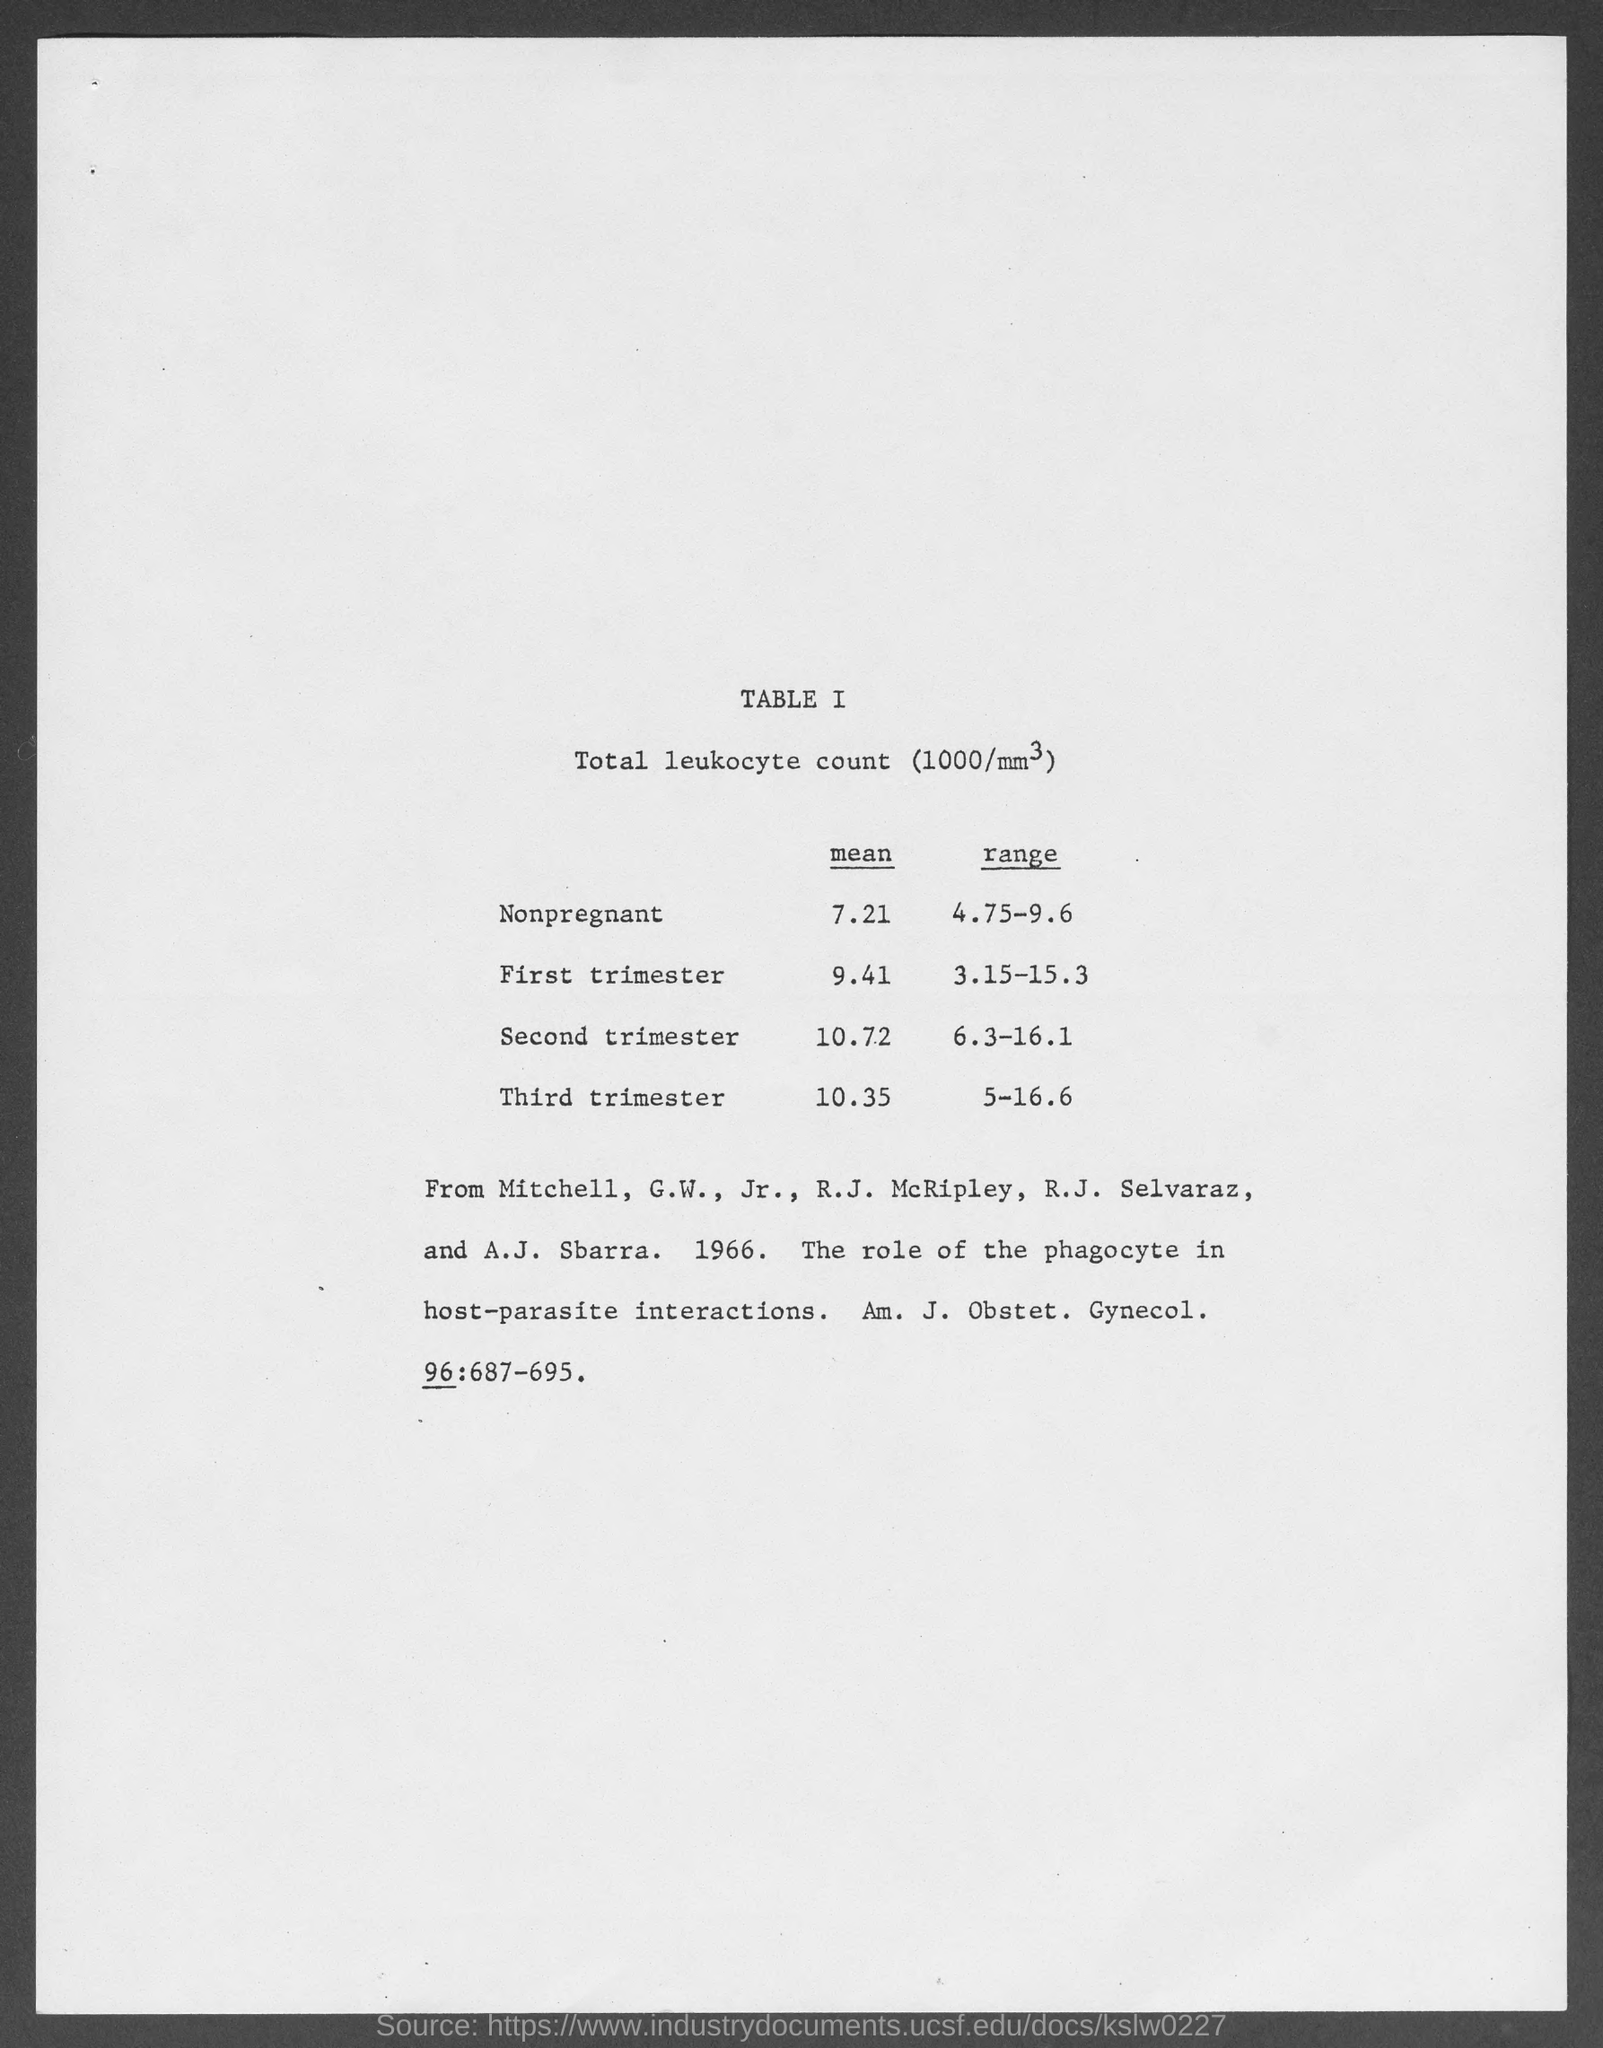Draw attention to some important aspects in this diagram. The table describes the total leukocyte count. In the third trimester of pregnancy, the range of total leukocyte count (1000/mm3) is typically between 5 and 16.6. The mean of the total leukocyte count in nonpregnant women is 7,210 cells per milliliter. The mean of the total leukocyte count in the first trimester is 9.41. The range of total leukocyte count (1000/mm3) in the first trimester is 3.15 to 15.3. 